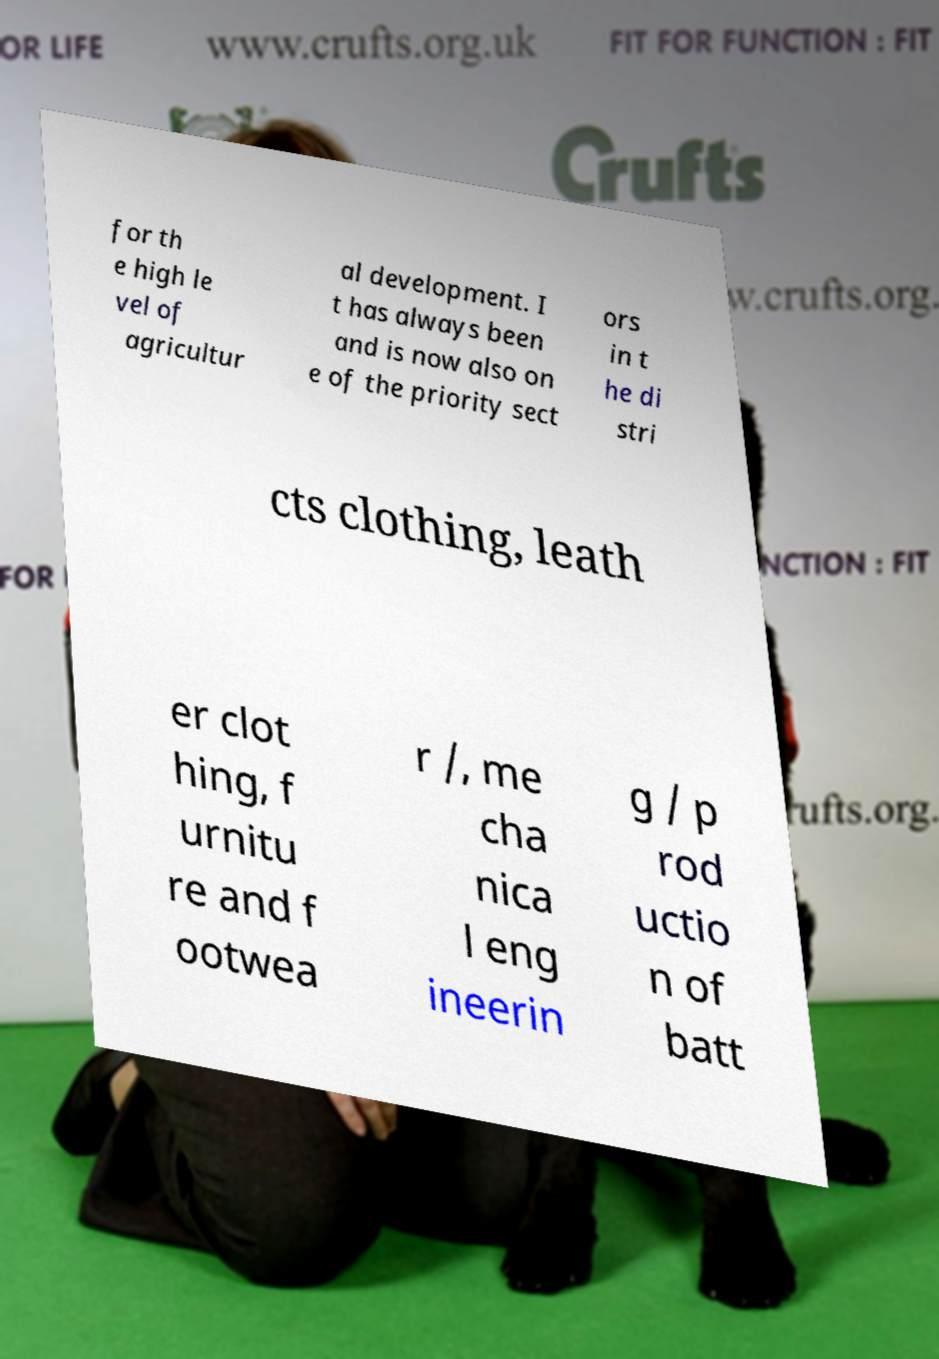What messages or text are displayed in this image? I need them in a readable, typed format. for th e high le vel of agricultur al development. I t has always been and is now also on e of the priority sect ors in t he di stri cts clothing, leath er clot hing, f urnitu re and f ootwea r /, me cha nica l eng ineerin g / p rod uctio n of batt 